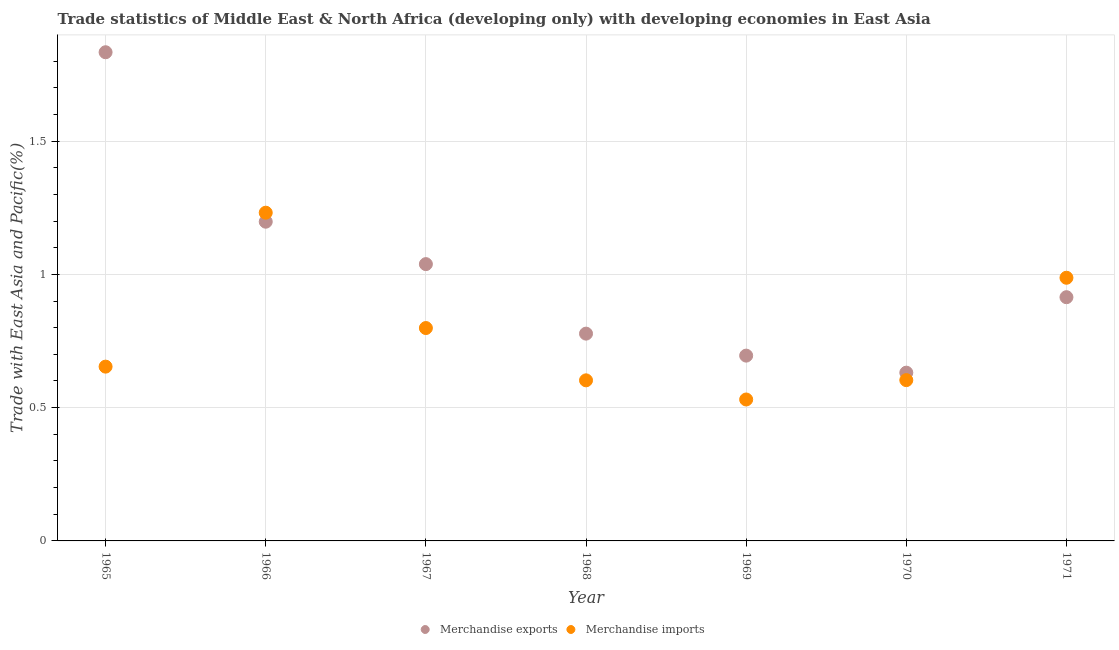What is the merchandise imports in 1965?
Keep it short and to the point. 0.65. Across all years, what is the maximum merchandise exports?
Your response must be concise. 1.83. Across all years, what is the minimum merchandise exports?
Your response must be concise. 0.63. In which year was the merchandise imports maximum?
Offer a very short reply. 1966. In which year was the merchandise exports minimum?
Make the answer very short. 1970. What is the total merchandise imports in the graph?
Offer a terse response. 5.41. What is the difference between the merchandise imports in 1968 and that in 1971?
Your response must be concise. -0.38. What is the difference between the merchandise exports in 1966 and the merchandise imports in 1968?
Your response must be concise. 0.6. What is the average merchandise exports per year?
Provide a succinct answer. 1.01. In the year 1968, what is the difference between the merchandise exports and merchandise imports?
Provide a succinct answer. 0.18. In how many years, is the merchandise exports greater than 1.2 %?
Your response must be concise. 1. What is the ratio of the merchandise exports in 1965 to that in 1970?
Your answer should be compact. 2.9. Is the difference between the merchandise exports in 1965 and 1968 greater than the difference between the merchandise imports in 1965 and 1968?
Provide a short and direct response. Yes. What is the difference between the highest and the second highest merchandise imports?
Your answer should be compact. 0.24. What is the difference between the highest and the lowest merchandise exports?
Provide a short and direct response. 1.2. In how many years, is the merchandise exports greater than the average merchandise exports taken over all years?
Provide a succinct answer. 3. Does the merchandise imports monotonically increase over the years?
Offer a very short reply. No. Is the merchandise exports strictly less than the merchandise imports over the years?
Your answer should be very brief. No. How many dotlines are there?
Make the answer very short. 2. How many years are there in the graph?
Keep it short and to the point. 7. What is the difference between two consecutive major ticks on the Y-axis?
Offer a terse response. 0.5. Are the values on the major ticks of Y-axis written in scientific E-notation?
Your answer should be compact. No. Does the graph contain any zero values?
Provide a short and direct response. No. Does the graph contain grids?
Provide a succinct answer. Yes. Where does the legend appear in the graph?
Offer a terse response. Bottom center. How many legend labels are there?
Provide a short and direct response. 2. What is the title of the graph?
Your answer should be very brief. Trade statistics of Middle East & North Africa (developing only) with developing economies in East Asia. Does "Imports" appear as one of the legend labels in the graph?
Your answer should be compact. No. What is the label or title of the Y-axis?
Offer a terse response. Trade with East Asia and Pacific(%). What is the Trade with East Asia and Pacific(%) of Merchandise exports in 1965?
Provide a short and direct response. 1.83. What is the Trade with East Asia and Pacific(%) of Merchandise imports in 1965?
Provide a short and direct response. 0.65. What is the Trade with East Asia and Pacific(%) of Merchandise exports in 1966?
Provide a succinct answer. 1.2. What is the Trade with East Asia and Pacific(%) in Merchandise imports in 1966?
Keep it short and to the point. 1.23. What is the Trade with East Asia and Pacific(%) of Merchandise exports in 1967?
Keep it short and to the point. 1.04. What is the Trade with East Asia and Pacific(%) in Merchandise imports in 1967?
Ensure brevity in your answer.  0.8. What is the Trade with East Asia and Pacific(%) of Merchandise exports in 1968?
Your answer should be compact. 0.78. What is the Trade with East Asia and Pacific(%) of Merchandise imports in 1968?
Provide a succinct answer. 0.6. What is the Trade with East Asia and Pacific(%) of Merchandise exports in 1969?
Keep it short and to the point. 0.7. What is the Trade with East Asia and Pacific(%) in Merchandise imports in 1969?
Offer a terse response. 0.53. What is the Trade with East Asia and Pacific(%) in Merchandise exports in 1970?
Keep it short and to the point. 0.63. What is the Trade with East Asia and Pacific(%) in Merchandise imports in 1970?
Your response must be concise. 0.6. What is the Trade with East Asia and Pacific(%) in Merchandise exports in 1971?
Offer a terse response. 0.91. What is the Trade with East Asia and Pacific(%) in Merchandise imports in 1971?
Offer a very short reply. 0.99. Across all years, what is the maximum Trade with East Asia and Pacific(%) of Merchandise exports?
Your answer should be very brief. 1.83. Across all years, what is the maximum Trade with East Asia and Pacific(%) of Merchandise imports?
Your answer should be compact. 1.23. Across all years, what is the minimum Trade with East Asia and Pacific(%) in Merchandise exports?
Make the answer very short. 0.63. Across all years, what is the minimum Trade with East Asia and Pacific(%) of Merchandise imports?
Your answer should be very brief. 0.53. What is the total Trade with East Asia and Pacific(%) in Merchandise exports in the graph?
Ensure brevity in your answer.  7.09. What is the total Trade with East Asia and Pacific(%) of Merchandise imports in the graph?
Provide a short and direct response. 5.41. What is the difference between the Trade with East Asia and Pacific(%) of Merchandise exports in 1965 and that in 1966?
Provide a succinct answer. 0.64. What is the difference between the Trade with East Asia and Pacific(%) of Merchandise imports in 1965 and that in 1966?
Your answer should be very brief. -0.58. What is the difference between the Trade with East Asia and Pacific(%) of Merchandise exports in 1965 and that in 1967?
Your response must be concise. 0.79. What is the difference between the Trade with East Asia and Pacific(%) of Merchandise imports in 1965 and that in 1967?
Provide a succinct answer. -0.14. What is the difference between the Trade with East Asia and Pacific(%) in Merchandise exports in 1965 and that in 1968?
Offer a terse response. 1.06. What is the difference between the Trade with East Asia and Pacific(%) of Merchandise imports in 1965 and that in 1968?
Your response must be concise. 0.05. What is the difference between the Trade with East Asia and Pacific(%) in Merchandise exports in 1965 and that in 1969?
Make the answer very short. 1.14. What is the difference between the Trade with East Asia and Pacific(%) in Merchandise imports in 1965 and that in 1969?
Ensure brevity in your answer.  0.12. What is the difference between the Trade with East Asia and Pacific(%) of Merchandise exports in 1965 and that in 1970?
Offer a very short reply. 1.2. What is the difference between the Trade with East Asia and Pacific(%) in Merchandise imports in 1965 and that in 1970?
Make the answer very short. 0.05. What is the difference between the Trade with East Asia and Pacific(%) of Merchandise exports in 1965 and that in 1971?
Keep it short and to the point. 0.92. What is the difference between the Trade with East Asia and Pacific(%) in Merchandise imports in 1965 and that in 1971?
Provide a succinct answer. -0.33. What is the difference between the Trade with East Asia and Pacific(%) in Merchandise exports in 1966 and that in 1967?
Provide a succinct answer. 0.16. What is the difference between the Trade with East Asia and Pacific(%) in Merchandise imports in 1966 and that in 1967?
Offer a very short reply. 0.43. What is the difference between the Trade with East Asia and Pacific(%) in Merchandise exports in 1966 and that in 1968?
Your answer should be compact. 0.42. What is the difference between the Trade with East Asia and Pacific(%) of Merchandise imports in 1966 and that in 1968?
Provide a short and direct response. 0.63. What is the difference between the Trade with East Asia and Pacific(%) in Merchandise exports in 1966 and that in 1969?
Your response must be concise. 0.5. What is the difference between the Trade with East Asia and Pacific(%) in Merchandise imports in 1966 and that in 1969?
Provide a short and direct response. 0.7. What is the difference between the Trade with East Asia and Pacific(%) in Merchandise exports in 1966 and that in 1970?
Your answer should be compact. 0.57. What is the difference between the Trade with East Asia and Pacific(%) of Merchandise imports in 1966 and that in 1970?
Offer a very short reply. 0.63. What is the difference between the Trade with East Asia and Pacific(%) in Merchandise exports in 1966 and that in 1971?
Offer a terse response. 0.28. What is the difference between the Trade with East Asia and Pacific(%) of Merchandise imports in 1966 and that in 1971?
Make the answer very short. 0.24. What is the difference between the Trade with East Asia and Pacific(%) in Merchandise exports in 1967 and that in 1968?
Your answer should be compact. 0.26. What is the difference between the Trade with East Asia and Pacific(%) of Merchandise imports in 1967 and that in 1968?
Your answer should be compact. 0.2. What is the difference between the Trade with East Asia and Pacific(%) of Merchandise exports in 1967 and that in 1969?
Give a very brief answer. 0.34. What is the difference between the Trade with East Asia and Pacific(%) of Merchandise imports in 1967 and that in 1969?
Offer a very short reply. 0.27. What is the difference between the Trade with East Asia and Pacific(%) in Merchandise exports in 1967 and that in 1970?
Provide a short and direct response. 0.41. What is the difference between the Trade with East Asia and Pacific(%) of Merchandise imports in 1967 and that in 1970?
Offer a very short reply. 0.2. What is the difference between the Trade with East Asia and Pacific(%) in Merchandise exports in 1967 and that in 1971?
Offer a very short reply. 0.12. What is the difference between the Trade with East Asia and Pacific(%) in Merchandise imports in 1967 and that in 1971?
Make the answer very short. -0.19. What is the difference between the Trade with East Asia and Pacific(%) in Merchandise exports in 1968 and that in 1969?
Your answer should be very brief. 0.08. What is the difference between the Trade with East Asia and Pacific(%) in Merchandise imports in 1968 and that in 1969?
Make the answer very short. 0.07. What is the difference between the Trade with East Asia and Pacific(%) of Merchandise exports in 1968 and that in 1970?
Offer a very short reply. 0.15. What is the difference between the Trade with East Asia and Pacific(%) of Merchandise imports in 1968 and that in 1970?
Give a very brief answer. -0. What is the difference between the Trade with East Asia and Pacific(%) in Merchandise exports in 1968 and that in 1971?
Offer a very short reply. -0.14. What is the difference between the Trade with East Asia and Pacific(%) in Merchandise imports in 1968 and that in 1971?
Make the answer very short. -0.38. What is the difference between the Trade with East Asia and Pacific(%) in Merchandise exports in 1969 and that in 1970?
Offer a very short reply. 0.06. What is the difference between the Trade with East Asia and Pacific(%) in Merchandise imports in 1969 and that in 1970?
Ensure brevity in your answer.  -0.07. What is the difference between the Trade with East Asia and Pacific(%) of Merchandise exports in 1969 and that in 1971?
Provide a succinct answer. -0.22. What is the difference between the Trade with East Asia and Pacific(%) in Merchandise imports in 1969 and that in 1971?
Offer a very short reply. -0.46. What is the difference between the Trade with East Asia and Pacific(%) of Merchandise exports in 1970 and that in 1971?
Offer a very short reply. -0.28. What is the difference between the Trade with East Asia and Pacific(%) in Merchandise imports in 1970 and that in 1971?
Keep it short and to the point. -0.38. What is the difference between the Trade with East Asia and Pacific(%) in Merchandise exports in 1965 and the Trade with East Asia and Pacific(%) in Merchandise imports in 1966?
Ensure brevity in your answer.  0.6. What is the difference between the Trade with East Asia and Pacific(%) in Merchandise exports in 1965 and the Trade with East Asia and Pacific(%) in Merchandise imports in 1967?
Your answer should be very brief. 1.03. What is the difference between the Trade with East Asia and Pacific(%) in Merchandise exports in 1965 and the Trade with East Asia and Pacific(%) in Merchandise imports in 1968?
Your answer should be compact. 1.23. What is the difference between the Trade with East Asia and Pacific(%) of Merchandise exports in 1965 and the Trade with East Asia and Pacific(%) of Merchandise imports in 1969?
Offer a very short reply. 1.3. What is the difference between the Trade with East Asia and Pacific(%) in Merchandise exports in 1965 and the Trade with East Asia and Pacific(%) in Merchandise imports in 1970?
Offer a very short reply. 1.23. What is the difference between the Trade with East Asia and Pacific(%) in Merchandise exports in 1965 and the Trade with East Asia and Pacific(%) in Merchandise imports in 1971?
Ensure brevity in your answer.  0.85. What is the difference between the Trade with East Asia and Pacific(%) of Merchandise exports in 1966 and the Trade with East Asia and Pacific(%) of Merchandise imports in 1967?
Your answer should be compact. 0.4. What is the difference between the Trade with East Asia and Pacific(%) of Merchandise exports in 1966 and the Trade with East Asia and Pacific(%) of Merchandise imports in 1968?
Your response must be concise. 0.6. What is the difference between the Trade with East Asia and Pacific(%) of Merchandise exports in 1966 and the Trade with East Asia and Pacific(%) of Merchandise imports in 1969?
Offer a terse response. 0.67. What is the difference between the Trade with East Asia and Pacific(%) in Merchandise exports in 1966 and the Trade with East Asia and Pacific(%) in Merchandise imports in 1970?
Your answer should be compact. 0.59. What is the difference between the Trade with East Asia and Pacific(%) of Merchandise exports in 1966 and the Trade with East Asia and Pacific(%) of Merchandise imports in 1971?
Your answer should be compact. 0.21. What is the difference between the Trade with East Asia and Pacific(%) in Merchandise exports in 1967 and the Trade with East Asia and Pacific(%) in Merchandise imports in 1968?
Keep it short and to the point. 0.44. What is the difference between the Trade with East Asia and Pacific(%) in Merchandise exports in 1967 and the Trade with East Asia and Pacific(%) in Merchandise imports in 1969?
Offer a terse response. 0.51. What is the difference between the Trade with East Asia and Pacific(%) in Merchandise exports in 1967 and the Trade with East Asia and Pacific(%) in Merchandise imports in 1970?
Provide a short and direct response. 0.44. What is the difference between the Trade with East Asia and Pacific(%) in Merchandise exports in 1967 and the Trade with East Asia and Pacific(%) in Merchandise imports in 1971?
Your answer should be compact. 0.05. What is the difference between the Trade with East Asia and Pacific(%) in Merchandise exports in 1968 and the Trade with East Asia and Pacific(%) in Merchandise imports in 1969?
Your answer should be very brief. 0.25. What is the difference between the Trade with East Asia and Pacific(%) of Merchandise exports in 1968 and the Trade with East Asia and Pacific(%) of Merchandise imports in 1970?
Give a very brief answer. 0.17. What is the difference between the Trade with East Asia and Pacific(%) in Merchandise exports in 1968 and the Trade with East Asia and Pacific(%) in Merchandise imports in 1971?
Your response must be concise. -0.21. What is the difference between the Trade with East Asia and Pacific(%) in Merchandise exports in 1969 and the Trade with East Asia and Pacific(%) in Merchandise imports in 1970?
Ensure brevity in your answer.  0.09. What is the difference between the Trade with East Asia and Pacific(%) in Merchandise exports in 1969 and the Trade with East Asia and Pacific(%) in Merchandise imports in 1971?
Your answer should be very brief. -0.29. What is the difference between the Trade with East Asia and Pacific(%) in Merchandise exports in 1970 and the Trade with East Asia and Pacific(%) in Merchandise imports in 1971?
Provide a succinct answer. -0.36. What is the average Trade with East Asia and Pacific(%) in Merchandise exports per year?
Ensure brevity in your answer.  1.01. What is the average Trade with East Asia and Pacific(%) in Merchandise imports per year?
Make the answer very short. 0.77. In the year 1965, what is the difference between the Trade with East Asia and Pacific(%) of Merchandise exports and Trade with East Asia and Pacific(%) of Merchandise imports?
Offer a terse response. 1.18. In the year 1966, what is the difference between the Trade with East Asia and Pacific(%) of Merchandise exports and Trade with East Asia and Pacific(%) of Merchandise imports?
Keep it short and to the point. -0.03. In the year 1967, what is the difference between the Trade with East Asia and Pacific(%) of Merchandise exports and Trade with East Asia and Pacific(%) of Merchandise imports?
Offer a very short reply. 0.24. In the year 1968, what is the difference between the Trade with East Asia and Pacific(%) in Merchandise exports and Trade with East Asia and Pacific(%) in Merchandise imports?
Give a very brief answer. 0.18. In the year 1969, what is the difference between the Trade with East Asia and Pacific(%) of Merchandise exports and Trade with East Asia and Pacific(%) of Merchandise imports?
Provide a succinct answer. 0.16. In the year 1970, what is the difference between the Trade with East Asia and Pacific(%) in Merchandise exports and Trade with East Asia and Pacific(%) in Merchandise imports?
Your response must be concise. 0.03. In the year 1971, what is the difference between the Trade with East Asia and Pacific(%) in Merchandise exports and Trade with East Asia and Pacific(%) in Merchandise imports?
Your answer should be very brief. -0.07. What is the ratio of the Trade with East Asia and Pacific(%) in Merchandise exports in 1965 to that in 1966?
Give a very brief answer. 1.53. What is the ratio of the Trade with East Asia and Pacific(%) of Merchandise imports in 1965 to that in 1966?
Make the answer very short. 0.53. What is the ratio of the Trade with East Asia and Pacific(%) of Merchandise exports in 1965 to that in 1967?
Ensure brevity in your answer.  1.77. What is the ratio of the Trade with East Asia and Pacific(%) of Merchandise imports in 1965 to that in 1967?
Give a very brief answer. 0.82. What is the ratio of the Trade with East Asia and Pacific(%) in Merchandise exports in 1965 to that in 1968?
Make the answer very short. 2.36. What is the ratio of the Trade with East Asia and Pacific(%) in Merchandise imports in 1965 to that in 1968?
Provide a short and direct response. 1.09. What is the ratio of the Trade with East Asia and Pacific(%) of Merchandise exports in 1965 to that in 1969?
Offer a terse response. 2.64. What is the ratio of the Trade with East Asia and Pacific(%) in Merchandise imports in 1965 to that in 1969?
Make the answer very short. 1.23. What is the ratio of the Trade with East Asia and Pacific(%) of Merchandise exports in 1965 to that in 1970?
Offer a terse response. 2.9. What is the ratio of the Trade with East Asia and Pacific(%) in Merchandise imports in 1965 to that in 1970?
Make the answer very short. 1.08. What is the ratio of the Trade with East Asia and Pacific(%) in Merchandise exports in 1965 to that in 1971?
Provide a succinct answer. 2. What is the ratio of the Trade with East Asia and Pacific(%) of Merchandise imports in 1965 to that in 1971?
Keep it short and to the point. 0.66. What is the ratio of the Trade with East Asia and Pacific(%) of Merchandise exports in 1966 to that in 1967?
Provide a short and direct response. 1.15. What is the ratio of the Trade with East Asia and Pacific(%) in Merchandise imports in 1966 to that in 1967?
Ensure brevity in your answer.  1.54. What is the ratio of the Trade with East Asia and Pacific(%) of Merchandise exports in 1966 to that in 1968?
Keep it short and to the point. 1.54. What is the ratio of the Trade with East Asia and Pacific(%) of Merchandise imports in 1966 to that in 1968?
Your answer should be compact. 2.04. What is the ratio of the Trade with East Asia and Pacific(%) of Merchandise exports in 1966 to that in 1969?
Give a very brief answer. 1.72. What is the ratio of the Trade with East Asia and Pacific(%) in Merchandise imports in 1966 to that in 1969?
Your answer should be compact. 2.32. What is the ratio of the Trade with East Asia and Pacific(%) of Merchandise exports in 1966 to that in 1970?
Your answer should be very brief. 1.9. What is the ratio of the Trade with East Asia and Pacific(%) in Merchandise imports in 1966 to that in 1970?
Ensure brevity in your answer.  2.04. What is the ratio of the Trade with East Asia and Pacific(%) in Merchandise exports in 1966 to that in 1971?
Make the answer very short. 1.31. What is the ratio of the Trade with East Asia and Pacific(%) of Merchandise imports in 1966 to that in 1971?
Provide a succinct answer. 1.25. What is the ratio of the Trade with East Asia and Pacific(%) of Merchandise exports in 1967 to that in 1968?
Ensure brevity in your answer.  1.34. What is the ratio of the Trade with East Asia and Pacific(%) in Merchandise imports in 1967 to that in 1968?
Offer a very short reply. 1.33. What is the ratio of the Trade with East Asia and Pacific(%) of Merchandise exports in 1967 to that in 1969?
Provide a short and direct response. 1.49. What is the ratio of the Trade with East Asia and Pacific(%) of Merchandise imports in 1967 to that in 1969?
Make the answer very short. 1.51. What is the ratio of the Trade with East Asia and Pacific(%) of Merchandise exports in 1967 to that in 1970?
Your answer should be compact. 1.65. What is the ratio of the Trade with East Asia and Pacific(%) of Merchandise imports in 1967 to that in 1970?
Offer a very short reply. 1.32. What is the ratio of the Trade with East Asia and Pacific(%) of Merchandise exports in 1967 to that in 1971?
Offer a very short reply. 1.14. What is the ratio of the Trade with East Asia and Pacific(%) in Merchandise imports in 1967 to that in 1971?
Make the answer very short. 0.81. What is the ratio of the Trade with East Asia and Pacific(%) in Merchandise exports in 1968 to that in 1969?
Offer a very short reply. 1.12. What is the ratio of the Trade with East Asia and Pacific(%) of Merchandise imports in 1968 to that in 1969?
Provide a succinct answer. 1.14. What is the ratio of the Trade with East Asia and Pacific(%) of Merchandise exports in 1968 to that in 1970?
Offer a terse response. 1.23. What is the ratio of the Trade with East Asia and Pacific(%) of Merchandise exports in 1968 to that in 1971?
Make the answer very short. 0.85. What is the ratio of the Trade with East Asia and Pacific(%) of Merchandise imports in 1968 to that in 1971?
Your response must be concise. 0.61. What is the ratio of the Trade with East Asia and Pacific(%) of Merchandise exports in 1969 to that in 1970?
Offer a terse response. 1.1. What is the ratio of the Trade with East Asia and Pacific(%) of Merchandise imports in 1969 to that in 1970?
Give a very brief answer. 0.88. What is the ratio of the Trade with East Asia and Pacific(%) of Merchandise exports in 1969 to that in 1971?
Provide a succinct answer. 0.76. What is the ratio of the Trade with East Asia and Pacific(%) of Merchandise imports in 1969 to that in 1971?
Offer a terse response. 0.54. What is the ratio of the Trade with East Asia and Pacific(%) in Merchandise exports in 1970 to that in 1971?
Offer a terse response. 0.69. What is the ratio of the Trade with East Asia and Pacific(%) in Merchandise imports in 1970 to that in 1971?
Provide a succinct answer. 0.61. What is the difference between the highest and the second highest Trade with East Asia and Pacific(%) in Merchandise exports?
Offer a terse response. 0.64. What is the difference between the highest and the second highest Trade with East Asia and Pacific(%) of Merchandise imports?
Your answer should be compact. 0.24. What is the difference between the highest and the lowest Trade with East Asia and Pacific(%) of Merchandise exports?
Your response must be concise. 1.2. What is the difference between the highest and the lowest Trade with East Asia and Pacific(%) of Merchandise imports?
Give a very brief answer. 0.7. 